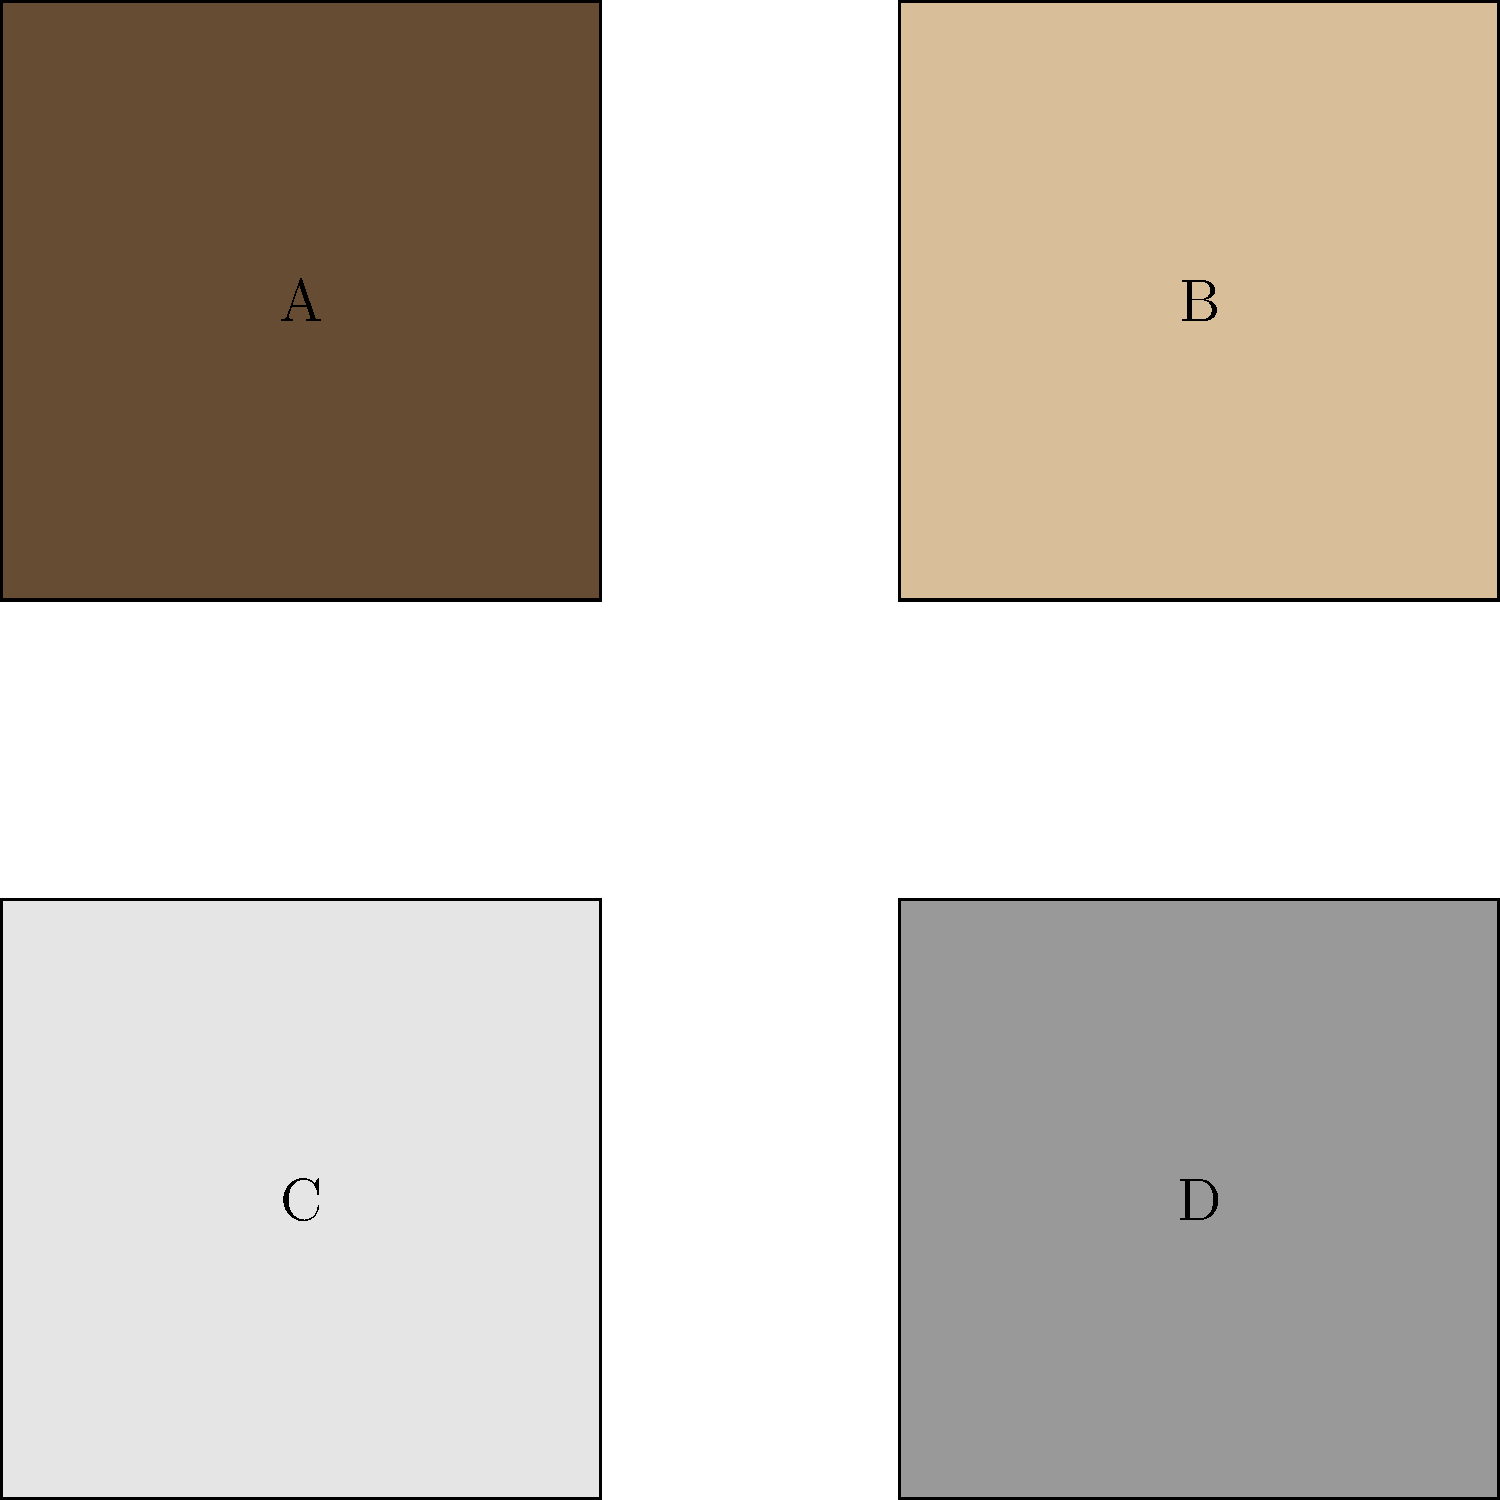Your son in the Army National Guard is being deployed to a snowy mountain region. Which camouflage pattern, represented by the squares above, would be most effective for this terrain? To determine the most effective camouflage pattern for a snowy mountain region, we need to consider the predominant color and texture of the environment:

1. Analyze the given options:
   A (top-left): Dark brown/green pattern, typical of woodland camouflage
   B (top-right): Light tan pattern, typical of desert camouflage
   C (bottom-left): White/light gray pattern, typical of snow camouflage
   D (bottom-right): Gray pattern, typical of urban camouflage

2. Consider the deployment environment:
   - Snowy mountain region
   - Predominant color: white

3. Match the environment to the camouflage options:
   - Snow is white, so the camouflage should be primarily white or very light gray
   - This will help the soldier blend in with the snowy surroundings

4. Evaluate each option:
   A: Too dark for snow, would stand out
   B: Too warm-toned for snow, would be visible
   C: Light-colored, matches snow
   D: Too dark for snow, would be noticeable

5. Conclusion:
   Option C (bottom-left) is the most suitable camouflage pattern for a snowy mountain region, as it closely matches the color of snow and would provide the best concealment in this environment.
Answer: C 